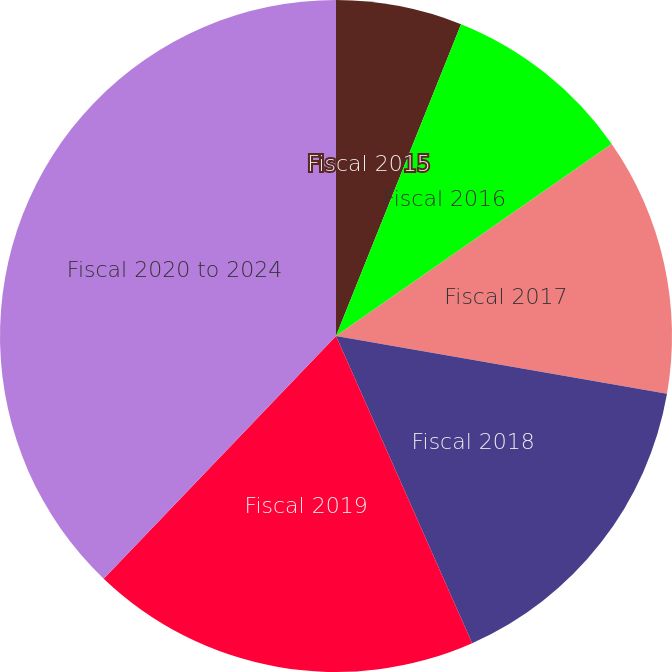Convert chart. <chart><loc_0><loc_0><loc_500><loc_500><pie_chart><fcel>Fiscal 2015<fcel>Fiscal 2016<fcel>Fiscal 2017<fcel>Fiscal 2018<fcel>Fiscal 2019<fcel>Fiscal 2020 to 2024<nl><fcel>6.07%<fcel>9.25%<fcel>12.43%<fcel>15.61%<fcel>18.79%<fcel>37.85%<nl></chart> 